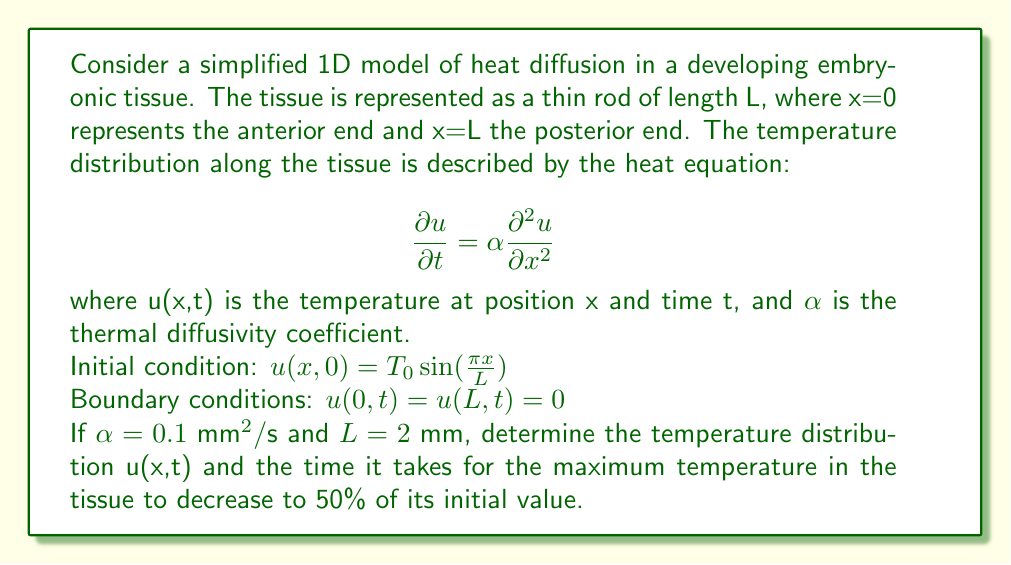Can you answer this question? To solve this problem, we'll follow these steps:

1) The general solution to the heat equation with the given boundary conditions is:

   $$u(x,t) = \sum_{n=1}^{\infty} B_n \sin(\frac{n\pi x}{L}) e^{-\alpha(\frac{n\pi}{L})^2t}$$

2) Given the initial condition, we can see that only the first term (n=1) is non-zero:

   $$u(x,0) = T_0 \sin(\frac{\pi x}{L}) = B_1 \sin(\frac{\pi x}{L})$$

   Therefore, $B_1 = T_0$ and all other $B_n = 0$ for $n > 1$.

3) The solution becomes:

   $$u(x,t) = T_0 \sin(\frac{\pi x}{L}) e^{-\alpha(\frac{\pi}{L})^2t}$$

4) The maximum temperature occurs at x = L/2 (the middle of the tissue):

   $$u_{max}(t) = T_0 \sin(\frac{\pi}{2}) e^{-\alpha(\frac{\pi}{L})^2t} = T_0 e^{-\alpha(\frac{\pi}{L})^2t}$$

5) To find when this maximum temperature decreases to 50% of its initial value:

   $$0.5T_0 = T_0 e^{-\alpha(\frac{\pi}{L})^2t}$$

   $$0.5 = e^{-\alpha(\frac{\pi}{L})^2t}$$

   $$\ln(0.5) = -\alpha(\frac{\pi}{L})^2t$$

   $$t = -\frac{L^2}{\alpha\pi^2}\ln(0.5)$$

6) Substituting the given values:

   $$t = -\frac{(2 \text{ mm})^2}{0.1 \text{ mm}^2/\text{s} \cdot \pi^2}\ln(0.5) \approx 8.80 \text{ s}$$

Thus, it takes approximately 8.80 seconds for the maximum temperature to decrease to 50% of its initial value.
Answer: $u(x,t) = T_0 \sin(\frac{\pi x}{L}) e^{-\alpha(\frac{\pi}{L})^2t}$; 8.80 seconds 